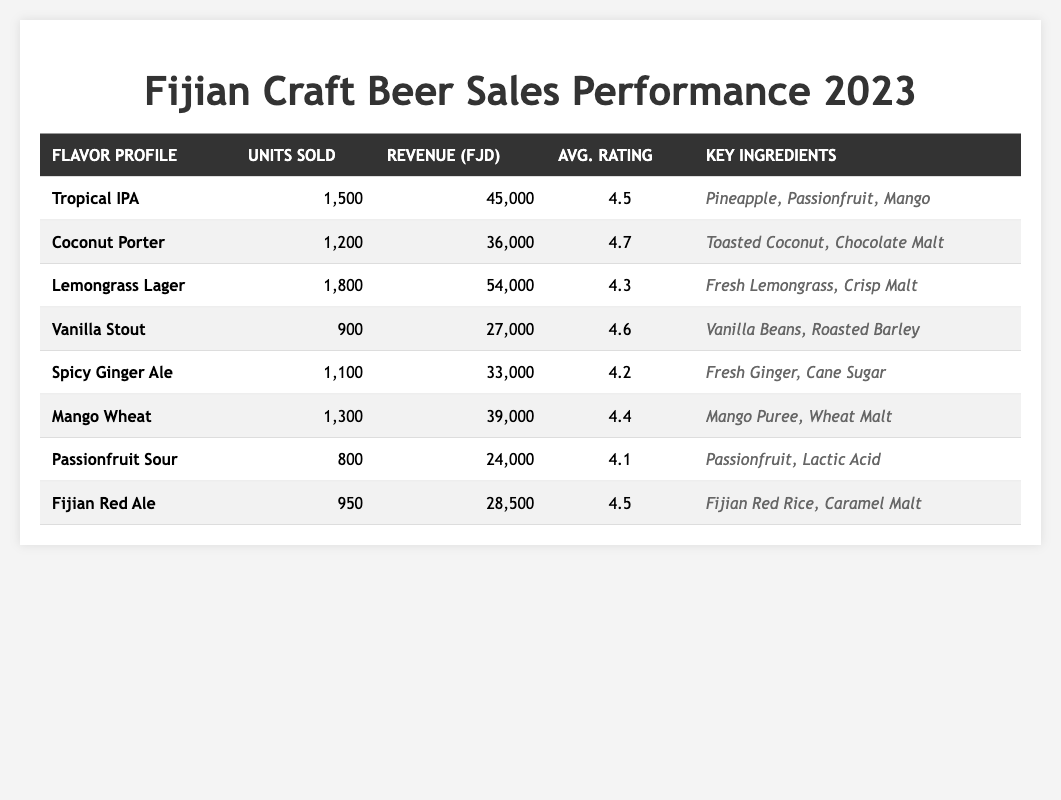What is the revenue generated from Tropical IPA? The revenue generated from Tropical IPA is directly listed in the table, which shows a value of 45,000.
Answer: 45,000 How many units of Vanilla Stout were sold? The table shows that 900 units of Vanilla Stout were sold, indicated in the "Units Sold" column.
Answer: 900 Which craft beer has the highest average rating? The highest average rating is 4.7 for the Coconut Porter, as seen in the "Avg. Rating" column.
Answer: Coconut Porter What is the total revenue from all craft beers sold? To find the total revenue, we add the revenues: 45,000 + 36,000 + 54,000 + 27,000 + 33,000 + 39,000 + 24,000 + 28,500 =  286,500.
Answer: 286,500 What is the average rating of all craft beers combined? First, sum the ratings: 4.5 + 4.7 + 4.3 + 4.6 + 4.2 + 4.4 + 4.1 + 4.5 =  34.3. There are 8 beers, so the average rating is 34.3 / 8 = 4.2875, rounded to 4.29.
Answer: 4.29 Did the Lemongrass Lager achieve more unit sales than the Coconut Porter? Lemongrass Lager sold 1,800 units while Coconut Porter sold 1,200 units, making it true that Lemongrass Lager has more unit sales.
Answer: Yes How much more revenue did Tropical IPA generate compared to Passionfruit Sour? The revenue from Tropical IPA is 45,000 and Passionfruit Sour is 24,000. The difference is 45,000 - 24,000 = 21,000.
Answer: 21,000 Which flavor profile generated the lowest revenue? By comparing the revenue figures, Passionfruit Sour generated the lowest revenue at 24,000.
Answer: Passionfruit Sour What percentage of units sold were for the Mango Wheat flavor profile? First, calculate the total units sold: 1,500 + 1,200 + 1,800 + 900 + 1,100 + 1,300 + 800 + 950 = 9,650. Mango Wheat sold 1,300 units. The percentage is (1,300 / 9,650) * 100 ≈ 13.46%.
Answer: 13.46% Which craft beer had the most key ingredients listed? The table does not specify the number of key ingredients, but by checking, Coconut Porter has 2 ingredients displayed, which is the same for all but Vanilla Stout shows 2 ingredients as well. Therefore, all equal in this case.
Answer: None, all have 2 ingredients How does the average rating of Spicy Ginger Ale compare to the overall average rating? The average rating of Spicy Ginger Ale is 4.2, and the overall average rating we calculated earlier is approximately 4.29. Since 4.2 is less than 4.29, it is below the overall average.
Answer: Below average 